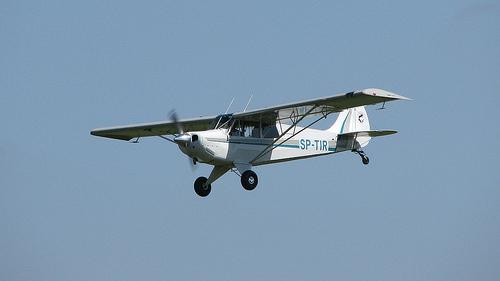Question: how is the weather?
Choices:
A. Cloudy.
B. It is raining.
C. Sunny.
D. It is snowing.
Answer with the letter. Answer: C Question: what color is the plane's lettering?
Choices:
A. White and Black.
B. Blue and Brown.
C. Red and blue.
D. Orange and Pink.
Answer with the letter. Answer: C 